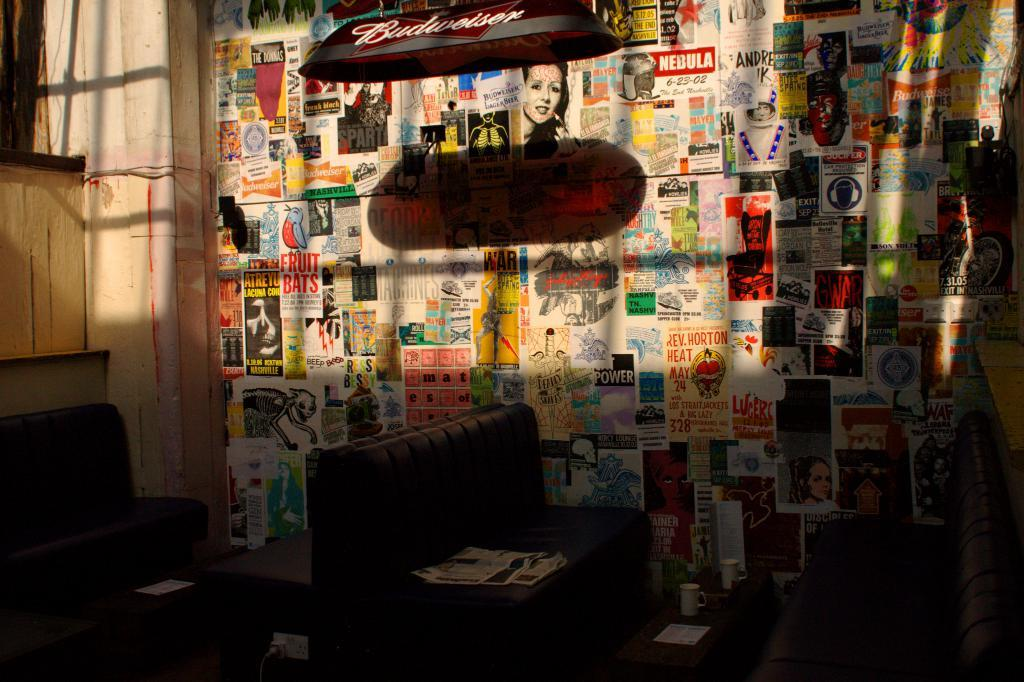What type of furniture is present in the image? There are sofas in the image. What object can be seen on the table in the image? There is a cup on the table in the image. What is the purpose of the light in the image? The light in the image provides illumination. What is the paper used for in the image? The paper in the image is likely used for writing or reading. How are the papers displayed on the wall in the image? The papers are stuck to the wall in the image. What type of bell can be heard ringing in the image? There is no bell present in the image, and therefore no sound can be heard. Is there a bridge visible in the image? There is no bridge present in the image. 